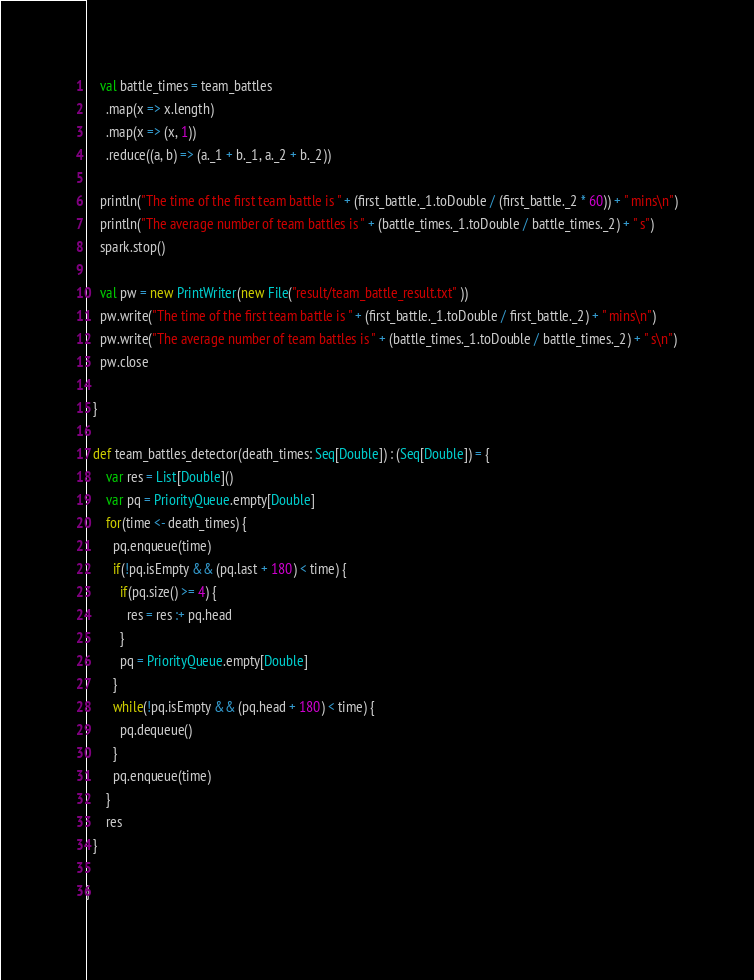<code> <loc_0><loc_0><loc_500><loc_500><_Scala_>    val battle_times = team_battles
      .map(x => x.length)
      .map(x => (x, 1))
      .reduce((a, b) => (a._1 + b._1, a._2 + b._2))

    println("The time of the first team battle is " + (first_battle._1.toDouble / (first_battle._2 * 60)) + " mins\n")
    println("The average number of team battles is " + (battle_times._1.toDouble / battle_times._2) + " s")
    spark.stop()

    val pw = new PrintWriter(new File("result/team_battle_result.txt" ))
    pw.write("The time of the first team battle is " + (first_battle._1.toDouble / first_battle._2) + " mins\n")
    pw.write("The average number of team battles is " + (battle_times._1.toDouble / battle_times._2) + " s\n")
    pw.close

  }

  def team_battles_detector(death_times: Seq[Double]) : (Seq[Double]) = {
      var res = List[Double]()
      var pq = PriorityQueue.empty[Double]
      for(time <- death_times) {
        pq.enqueue(time)
        if(!pq.isEmpty && (pq.last + 180) < time) {
          if(pq.size() >= 4) {
            res = res :+ pq.head
          }
          pq = PriorityQueue.empty[Double]
        }
        while(!pq.isEmpty && (pq.head + 180) < time) {
          pq.dequeue()
        }
        pq.enqueue(time)
      }
      res
  }

}</code> 